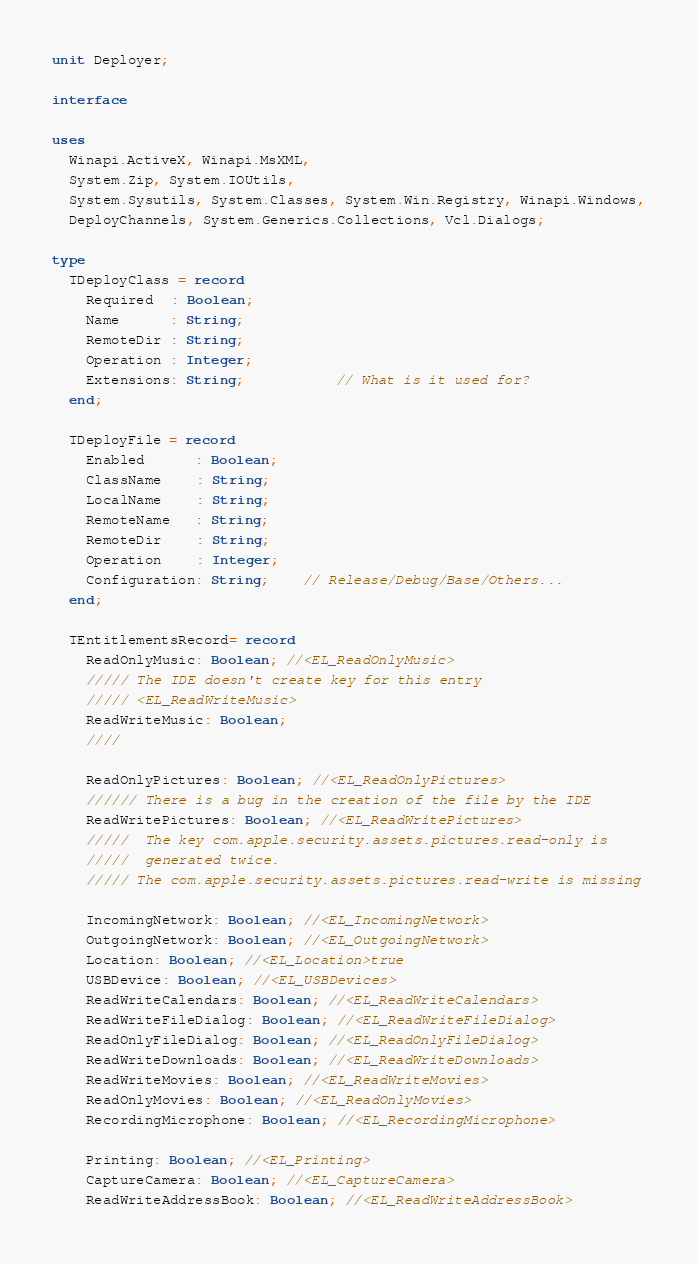<code> <loc_0><loc_0><loc_500><loc_500><_Pascal_>unit Deployer;

interface

uses
  Winapi.ActiveX, Winapi.MsXML,
  System.Zip, System.IOUtils,
  System.Sysutils, System.Classes, System.Win.Registry, Winapi.Windows,
  DeployChannels, System.Generics.Collections, Vcl.Dialogs;

type
  TDeployClass = record
    Required  : Boolean;
    Name      : String;
    RemoteDir : String;
    Operation : Integer;
    Extensions: String;           // What is it used for?
  end;

  TDeployFile = record
    Enabled      : Boolean;
    ClassName    : String;
    LocalName    : String;
    RemoteName   : String;
    RemoteDir    : String;
    Operation    : Integer;
    Configuration: String;    // Release/Debug/Base/Others...
  end;

  TEntitlementsRecord= record
    ReadOnlyMusic: Boolean; //<EL_ReadOnlyMusic>
    ///// The IDE doesn't create key for this entry
    ///// <EL_ReadWriteMusic>
    ReadWriteMusic: Boolean;
    ////

    ReadOnlyPictures: Boolean; //<EL_ReadOnlyPictures>
    ////// There is a bug in the creation of the file by the IDE
    ReadWritePictures: Boolean; //<EL_ReadWritePictures>
    /////  The key com.apple.security.assets.pictures.read-only is
    /////  generated twice.
    ///// The com.apple.security.assets.pictures.read-write is missing

    IncomingNetwork: Boolean; //<EL_IncomingNetwork>
    OutgoingNetwork: Boolean; //<EL_OutgoingNetwork>
    Location: Boolean; //<EL_Location>true
    USBDevice: Boolean; //<EL_USBDevices>
    ReadWriteCalendars: Boolean; //<EL_ReadWriteCalendars>
    ReadWriteFileDialog: Boolean; //<EL_ReadWriteFileDialog>
    ReadOnlyFileDialog: Boolean; //<EL_ReadOnlyFileDialog>
    ReadWriteDownloads: Boolean; //<EL_ReadWriteDownloads>
    ReadWriteMovies: Boolean; //<EL_ReadWriteMovies>
    ReadOnlyMovies: Boolean; //<EL_ReadOnlyMovies>
    RecordingMicrophone: Boolean; //<EL_RecordingMicrophone>

    Printing: Boolean; //<EL_Printing>
    CaptureCamera: Boolean; //<EL_CaptureCamera>
    ReadWriteAddressBook: Boolean; //<EL_ReadWriteAddressBook></code> 